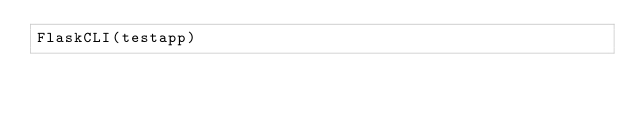Convert code to text. <code><loc_0><loc_0><loc_500><loc_500><_Python_>FlaskCLI(testapp)
</code> 